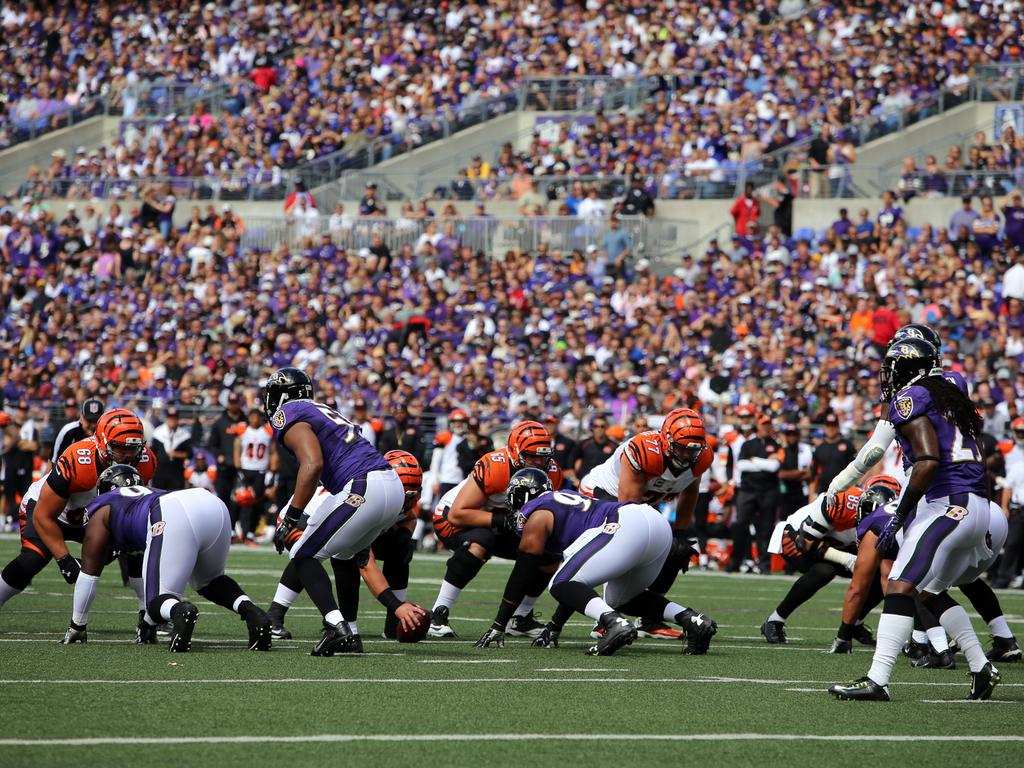What are the players in the image wearing? The players in the image are wearing different color dresses. What object is being used by the players in the image? There is a ball in the image. What can be seen in the background of the image? There are railings visible in the background of the image. What else can be seen in the background of the image? There is a group of people sitting in the background of the image. Where is the baby playing with the farmer in the image? There is no baby or farmer present in the image. What is the edge of the image used for? The edge of the image is not a physical object in the scene; it is simply the boundary of the photograph. 